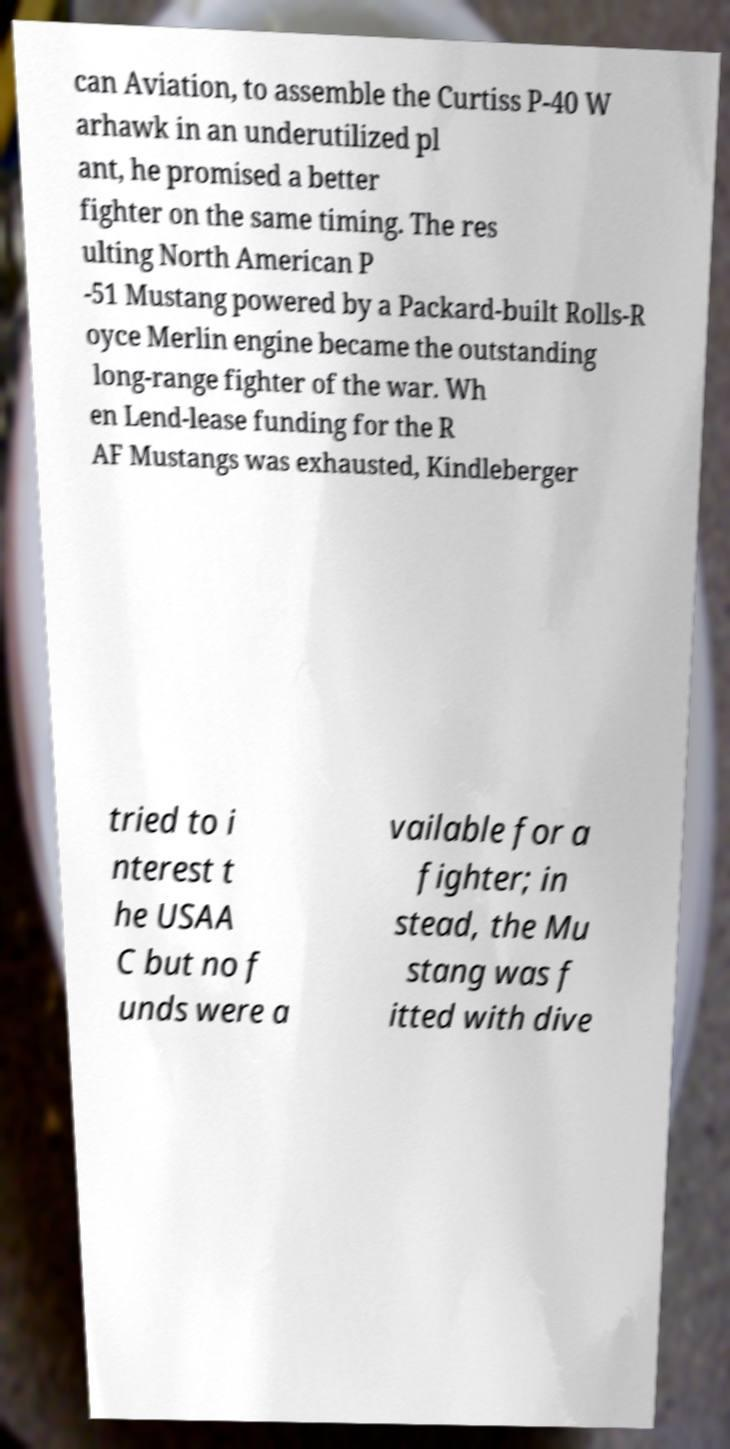Please identify and transcribe the text found in this image. can Aviation, to assemble the Curtiss P-40 W arhawk in an underutilized pl ant, he promised a better fighter on the same timing. The res ulting North American P -51 Mustang powered by a Packard-built Rolls-R oyce Merlin engine became the outstanding long-range fighter of the war. Wh en Lend-lease funding for the R AF Mustangs was exhausted, Kindleberger tried to i nterest t he USAA C but no f unds were a vailable for a fighter; in stead, the Mu stang was f itted with dive 